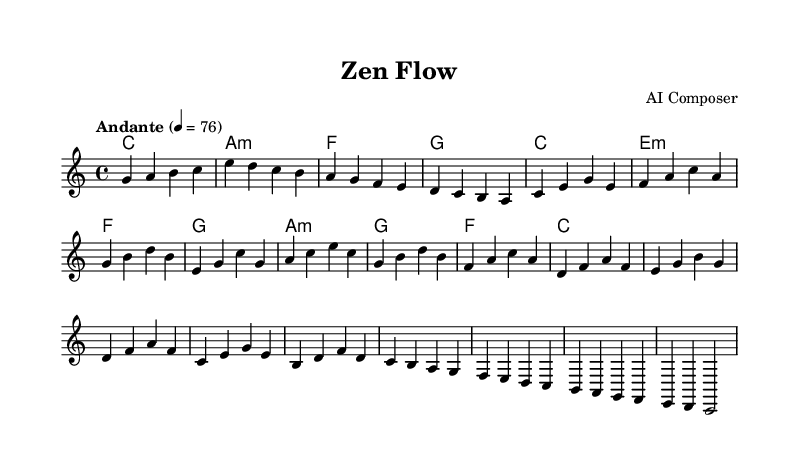What is the key signature of this music? The key signature is C major, which is indicated by the absence of any sharps or flats in the sheet music.
Answer: C major What is the time signature of this music? The time signature is 4/4, which means there are four beats per measure and each quarter note gets one beat, as shown at the beginning of the sheet music.
Answer: 4/4 What is the tempo marking of the piece? The tempo marking is "Andante," which indicates a moderate pace, and the tempo is set to 76 beats per minute as specified in the sheet music.
Answer: Andante How many main themes are presented in the music? There are two main themes labeled as Main Theme A and Main Theme B, which can be clearly identified in the structure of the music.
Answer: 2 What is the final chord in the piece? The final chord is C major, which can be determined by looking at the last harmony indicated in the sheet music prior to the final melody notes.
Answer: C What is the structure of the piece? The structure of the piece consists of an intro, two main themes (A and B), an interlude, and an outro, as observed from the delineation and labels in the sheet music.
Answer: Intro, Main Themes A & B, Interlude, Outro Which instrument is primarily represented in the score? The score primarily represents a staff for piano or similar instrumentation, as indicated by the traditional format of a single staff melody with chord symbols above.
Answer: Piano 